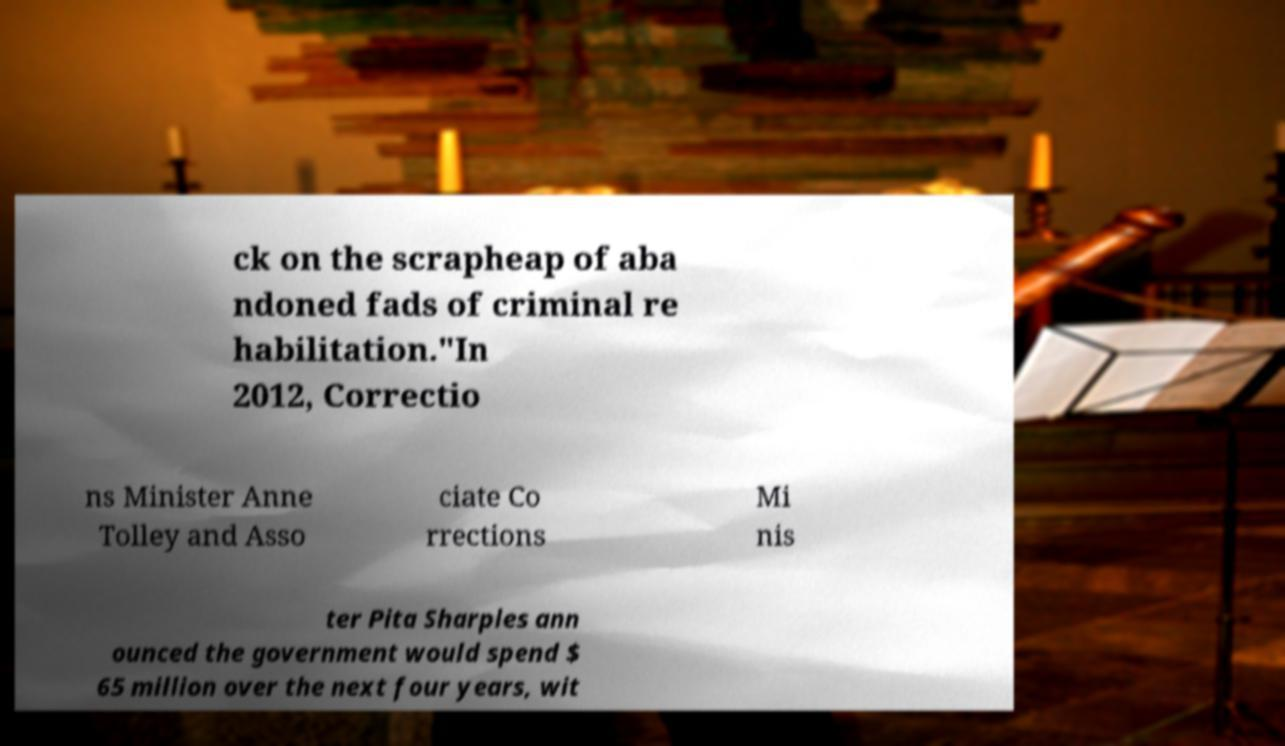For documentation purposes, I need the text within this image transcribed. Could you provide that? ck on the scrapheap of aba ndoned fads of criminal re habilitation."In 2012, Correctio ns Minister Anne Tolley and Asso ciate Co rrections Mi nis ter Pita Sharples ann ounced the government would spend $ 65 million over the next four years, wit 